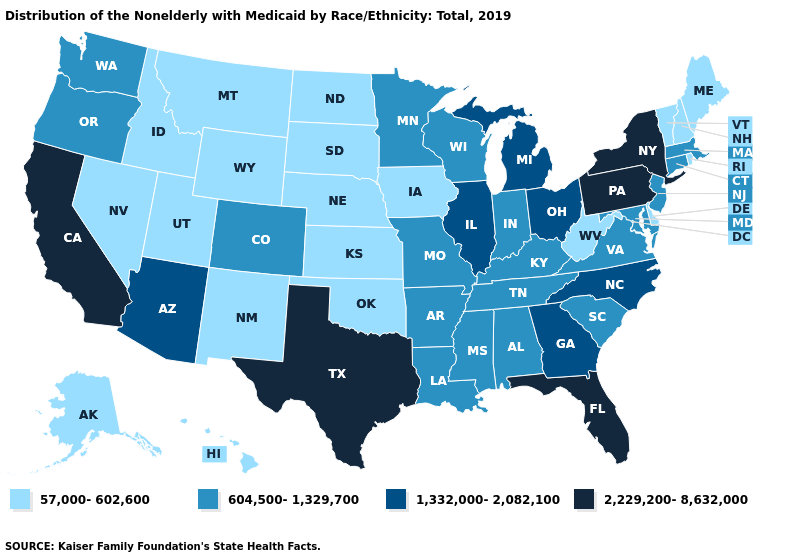What is the value of Oregon?
Concise answer only. 604,500-1,329,700. Among the states that border California , does Nevada have the highest value?
Concise answer only. No. Does Tennessee have the highest value in the South?
Answer briefly. No. What is the lowest value in states that border Mississippi?
Concise answer only. 604,500-1,329,700. Name the states that have a value in the range 604,500-1,329,700?
Write a very short answer. Alabama, Arkansas, Colorado, Connecticut, Indiana, Kentucky, Louisiana, Maryland, Massachusetts, Minnesota, Mississippi, Missouri, New Jersey, Oregon, South Carolina, Tennessee, Virginia, Washington, Wisconsin. Name the states that have a value in the range 57,000-602,600?
Answer briefly. Alaska, Delaware, Hawaii, Idaho, Iowa, Kansas, Maine, Montana, Nebraska, Nevada, New Hampshire, New Mexico, North Dakota, Oklahoma, Rhode Island, South Dakota, Utah, Vermont, West Virginia, Wyoming. Does Louisiana have a lower value than Texas?
Concise answer only. Yes. Name the states that have a value in the range 2,229,200-8,632,000?
Write a very short answer. California, Florida, New York, Pennsylvania, Texas. Among the states that border South Carolina , which have the highest value?
Keep it brief. Georgia, North Carolina. What is the value of New Hampshire?
Short answer required. 57,000-602,600. Name the states that have a value in the range 1,332,000-2,082,100?
Keep it brief. Arizona, Georgia, Illinois, Michigan, North Carolina, Ohio. Does Oregon have the highest value in the West?
Quick response, please. No. Does the first symbol in the legend represent the smallest category?
Quick response, please. Yes. What is the value of California?
Answer briefly. 2,229,200-8,632,000. Is the legend a continuous bar?
Write a very short answer. No. 